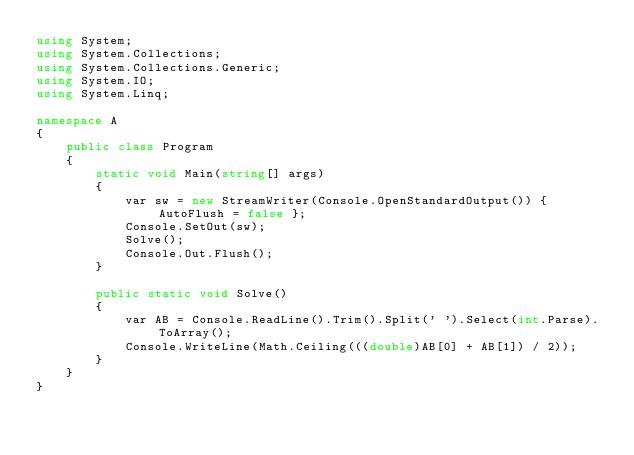<code> <loc_0><loc_0><loc_500><loc_500><_C#_>using System;
using System.Collections;
using System.Collections.Generic;
using System.IO;
using System.Linq;

namespace A
{
    public class Program
    {
        static void Main(string[] args)
        {
            var sw = new StreamWriter(Console.OpenStandardOutput()) { AutoFlush = false };
            Console.SetOut(sw);
            Solve();
            Console.Out.Flush();
        }

        public static void Solve()
        {
            var AB = Console.ReadLine().Trim().Split(' ').Select(int.Parse).ToArray();
            Console.WriteLine(Math.Ceiling(((double)AB[0] + AB[1]) / 2));
        }
    }
}
</code> 